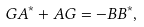Convert formula to latex. <formula><loc_0><loc_0><loc_500><loc_500>G A ^ { * } + A G = - B B ^ { * } ,</formula> 